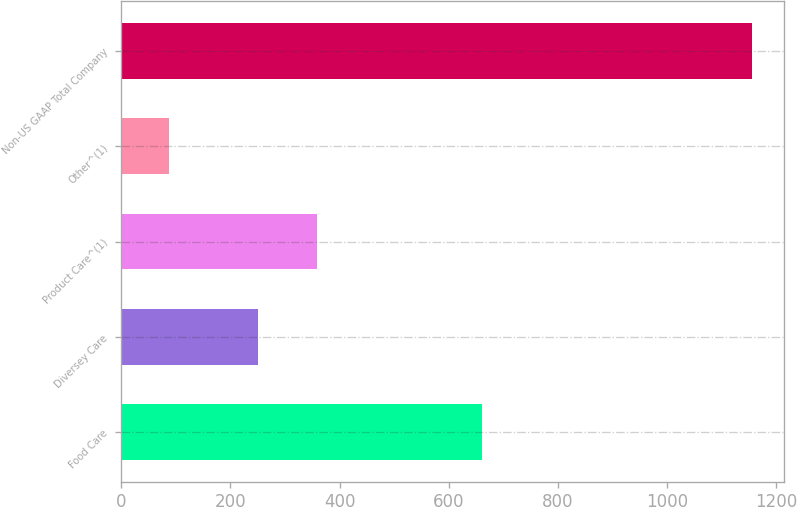Convert chart. <chart><loc_0><loc_0><loc_500><loc_500><bar_chart><fcel>Food Care<fcel>Diversey Care<fcel>Product Care^(1)<fcel>Other^(1)<fcel>Non-US GAAP Total Company<nl><fcel>661.1<fcel>251.3<fcel>358.28<fcel>87.2<fcel>1157<nl></chart> 